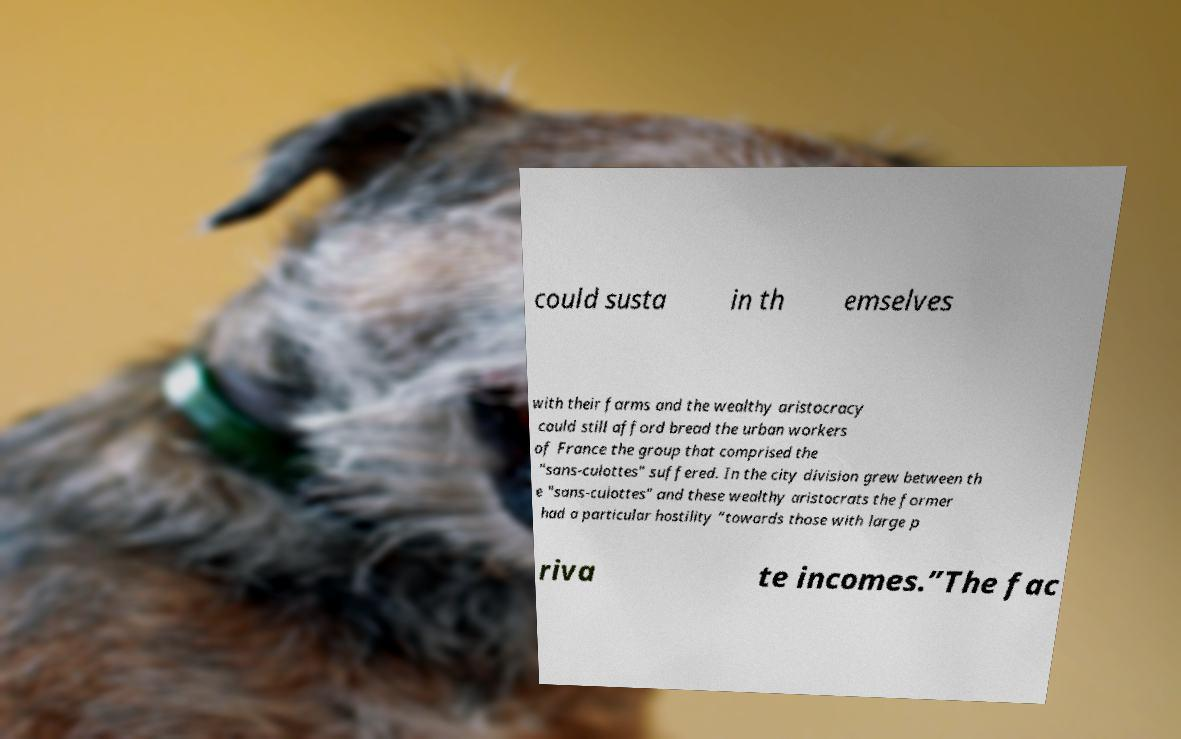There's text embedded in this image that I need extracted. Can you transcribe it verbatim? could susta in th emselves with their farms and the wealthy aristocracy could still afford bread the urban workers of France the group that comprised the "sans-culottes" suffered. In the city division grew between th e "sans-culottes" and these wealthy aristocrats the former had a particular hostility “towards those with large p riva te incomes.”The fac 